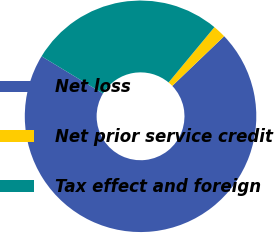Convert chart to OTSL. <chart><loc_0><loc_0><loc_500><loc_500><pie_chart><fcel>Net loss<fcel>Net prior service credit<fcel>Tax effect and foreign<nl><fcel>70.83%<fcel>1.83%<fcel>27.34%<nl></chart> 